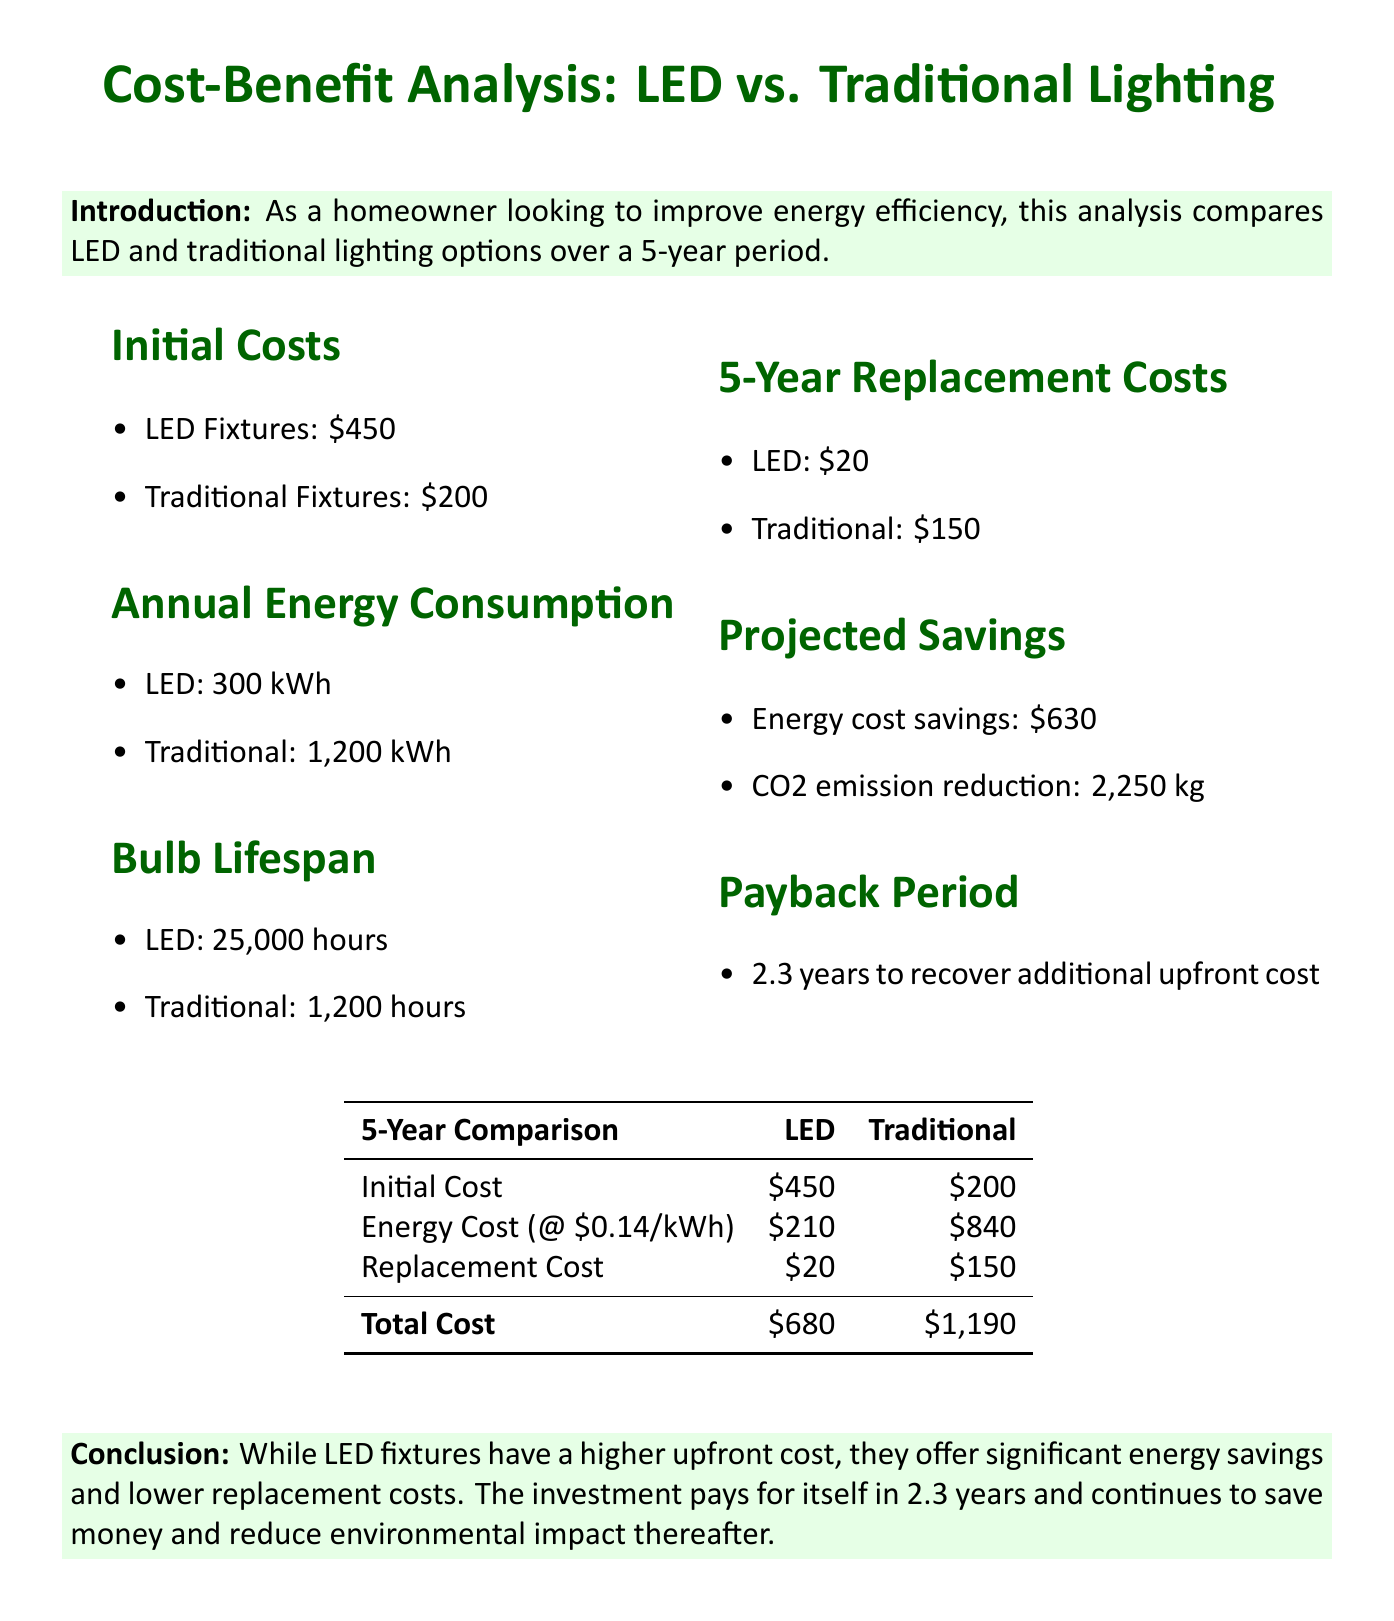what is the average cost of LED fixtures? The document states that the average cost of LED fixtures for a 3-bedroom home is $450.
Answer: $450 what is the annual energy consumption for traditional lighting? The annual energy consumption for traditional lighting is provided as 1200 kWh in the document.
Answer: 1200 kWh what is the estimated energy cost savings over 5 years with LED lighting? The document indicates that the estimated energy cost savings over 5 years with LED lighting is $630.
Answer: $630 how long does it take to recover the additional upfront cost of LED fixtures? The payback period noted in the document is 2.3 years to recover the additional upfront cost of LED fixtures.
Answer: 2.3 years what is the total cost for traditional lighting over 5 years? The total cost for traditional lighting over 5 years is given as $1,190 in the document.
Answer: $1,190 what is the average lifespan of LED bulbs? The document states that the average lifespan of LED bulbs is 25,000 hours.
Answer: 25,000 hours what is the reduction in CO2 emissions over 5 years with LED lighting? According to the document, the reduction in CO2 emissions over 5 years with LED lighting is 2,250 kg.
Answer: 2,250 kg what is the estimated replacement cost for traditional bulbs over 5 years? The estimated replacement cost for traditional bulbs over 5 years is stated as $150 in the document.
Answer: $150 what is the average residential electricity rate mentioned? The average residential electricity rate indicated in the document is $0.14 per kWh.
Answer: $0.14 per kWh 